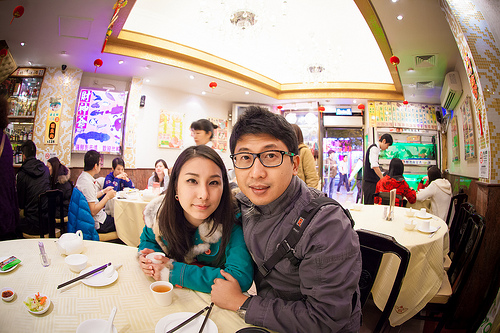<image>
Can you confirm if the chopstick is on the table? No. The chopstick is not positioned on the table. They may be near each other, but the chopstick is not supported by or resting on top of the table. Where is the bowl in relation to the chopstick? Is it in front of the chopstick? Yes. The bowl is positioned in front of the chopstick, appearing closer to the camera viewpoint. 